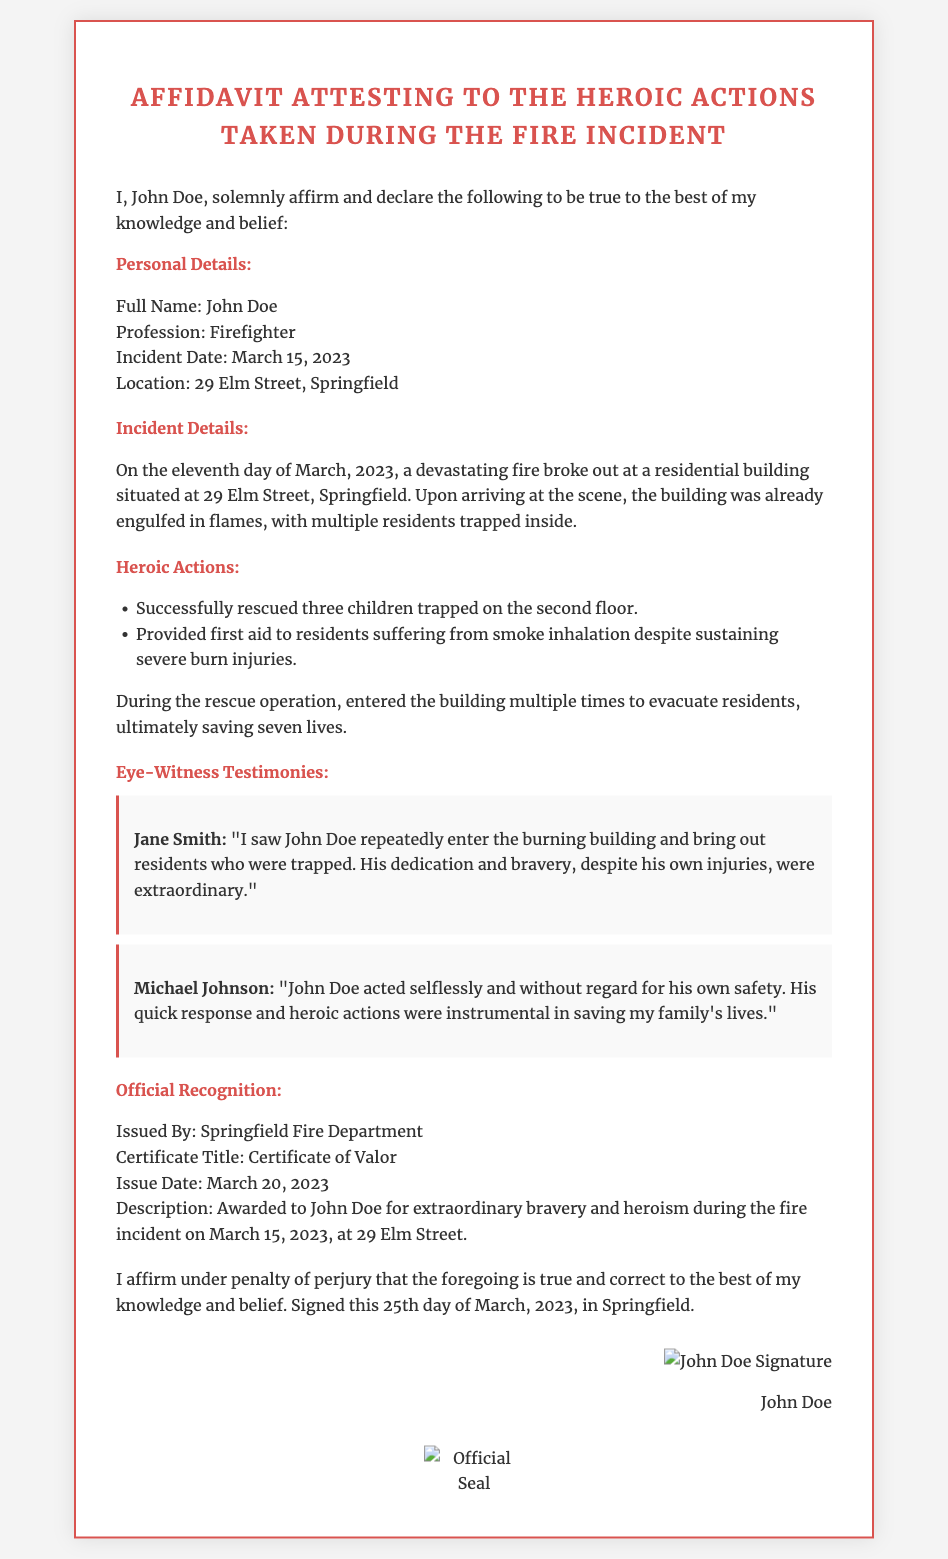What is the full name of the affiant? The full name is provided in the personal details section of the affidavit.
Answer: John Doe What was the profession of the affiant? The affiant's profession is stated in the personal details section.
Answer: Firefighter On what date did the fire incident occur? The date of the incident is mentioned in the personal details section.
Answer: March 15, 2023 How many lives did John Doe save during the incident? The number of lives saved is mentioned in the heroic actions section of the document.
Answer: Seven Who issued the Certificate of Valor? The organization that issued the certificate is stated in the official recognition section.
Answer: Springfield Fire Department What title was awarded to John Doe? The title given in recognition of John Doe's actions is listed in the official recognition section.
Answer: Certificate of Valor Why was John Doe awarded the Certificate of Valor? The reason for the award is explained in the official recognition section.
Answer: Extraordinary bravery and heroism during the fire incident Who provided the testimony mentioning John's dedication and bravery? One of the eye-witness testimonies identifies the person who acknowledged John’s bravery.
Answer: Jane Smith What injury did John Doe sustain while rescuing others? The type of injury sustained by John Doe is mentioned in the heroic actions section.
Answer: Severe burn injuries 